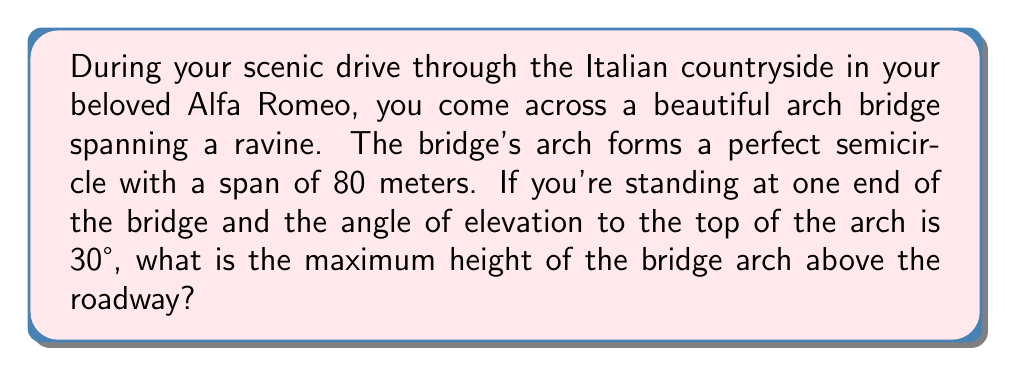Give your solution to this math problem. Let's approach this step-by-step:

1) First, let's visualize the problem:
   [asy]
   import geometry;
   
   size(200);
   
   pair A = (0,0), B = (8,0), C = (4,4);
   draw(A--B--C--cycle);
   draw(Arc(C,4,180,360));
   
   label("80m", (4,-0.5));
   label("h", (4.2,2));
   label("30°", (0.5,0.3));
   label("r", (2,2.5), align=NW);
   
   draw(A--(0,4), dashed);
   [/asy]

2) The span of the bridge (80 meters) is the diameter of the semicircle. Therefore, the radius (r) is half of this:
   
   $r = \frac{80}{2} = 40$ meters

3) In a right-angled triangle formed by the radius, half the span, and the height:
   
   $\tan 30° = \frac{h}{40}$

4) We know that $\tan 30° = \frac{1}{\sqrt{3}}$, so:

   $\frac{1}{\sqrt{3}} = \frac{h}{40}$

5) Cross-multiply:

   $40 = h\sqrt{3}$

6) Solve for h:

   $h = \frac{40}{\sqrt{3}} = 40 \cdot \frac{\sqrt{3}}{3} \approx 23.09$ meters

Therefore, the maximum height of the bridge arch is approximately 23.09 meters above the roadway.
Answer: $\frac{40\sqrt{3}}{3}$ meters or approximately 23.09 meters 